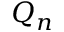Convert formula to latex. <formula><loc_0><loc_0><loc_500><loc_500>Q _ { n }</formula> 